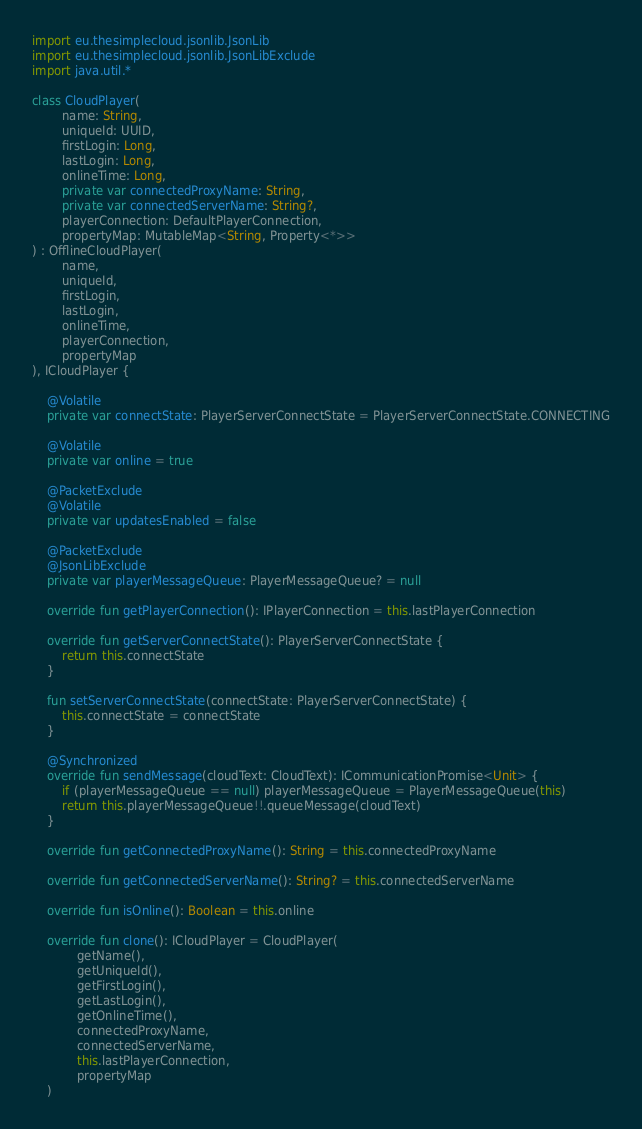Convert code to text. <code><loc_0><loc_0><loc_500><loc_500><_Kotlin_>import eu.thesimplecloud.jsonlib.JsonLib
import eu.thesimplecloud.jsonlib.JsonLibExclude
import java.util.*

class CloudPlayer(
        name: String,
        uniqueId: UUID,
        firstLogin: Long,
        lastLogin: Long,
        onlineTime: Long,
        private var connectedProxyName: String,
        private var connectedServerName: String?,
        playerConnection: DefaultPlayerConnection,
        propertyMap: MutableMap<String, Property<*>>
) : OfflineCloudPlayer(
        name,
        uniqueId,
        firstLogin,
        lastLogin,
        onlineTime,
        playerConnection,
        propertyMap
), ICloudPlayer {

    @Volatile
    private var connectState: PlayerServerConnectState = PlayerServerConnectState.CONNECTING

    @Volatile
    private var online = true

    @PacketExclude
    @Volatile
    private var updatesEnabled = false

    @PacketExclude
    @JsonLibExclude
    private var playerMessageQueue: PlayerMessageQueue? = null

    override fun getPlayerConnection(): IPlayerConnection = this.lastPlayerConnection

    override fun getServerConnectState(): PlayerServerConnectState {
        return this.connectState
    }

    fun setServerConnectState(connectState: PlayerServerConnectState) {
        this.connectState = connectState
    }

    @Synchronized
    override fun sendMessage(cloudText: CloudText): ICommunicationPromise<Unit> {
        if (playerMessageQueue == null) playerMessageQueue = PlayerMessageQueue(this)
        return this.playerMessageQueue!!.queueMessage(cloudText)
    }

    override fun getConnectedProxyName(): String = this.connectedProxyName

    override fun getConnectedServerName(): String? = this.connectedServerName

    override fun isOnline(): Boolean = this.online

    override fun clone(): ICloudPlayer = CloudPlayer(
            getName(),
            getUniqueId(),
            getFirstLogin(),
            getLastLogin(),
            getOnlineTime(),
            connectedProxyName,
            connectedServerName,
            this.lastPlayerConnection,
            propertyMap
    )
</code> 